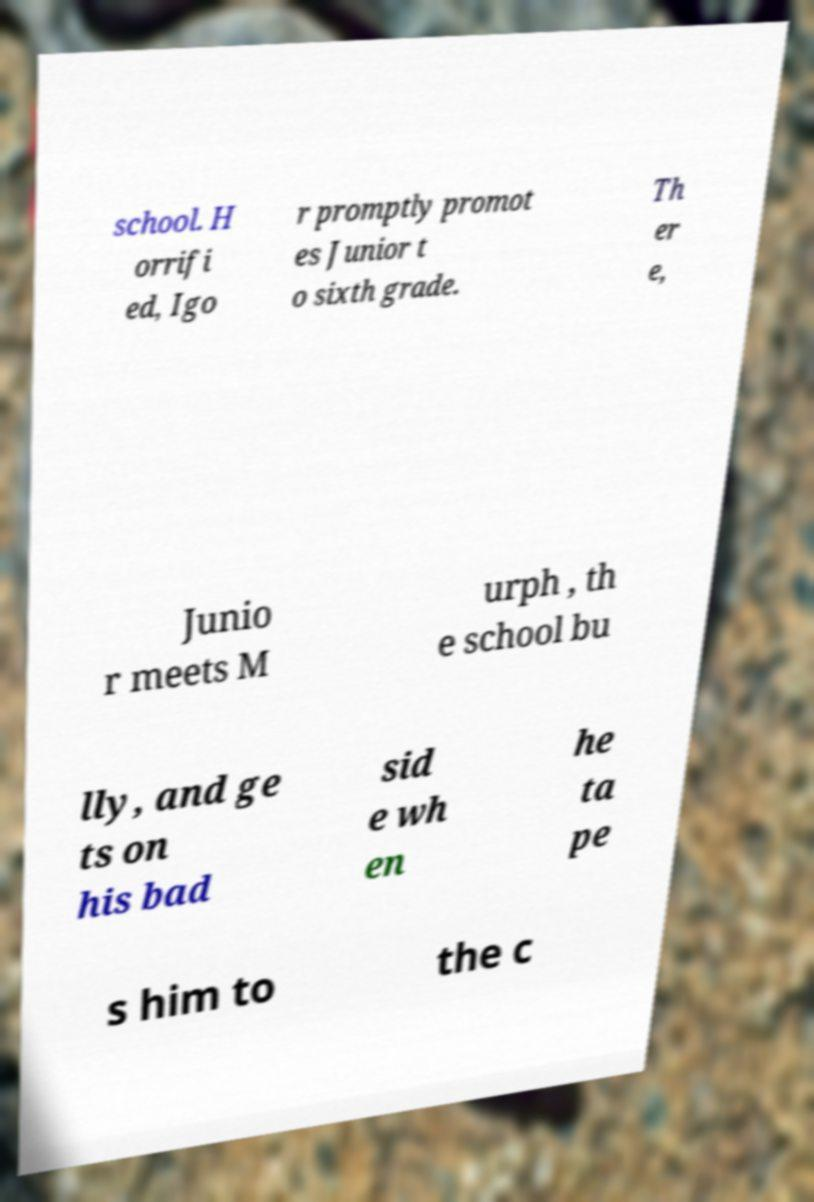What messages or text are displayed in this image? I need them in a readable, typed format. school. H orrifi ed, Igo r promptly promot es Junior t o sixth grade. Th er e, Junio r meets M urph , th e school bu lly, and ge ts on his bad sid e wh en he ta pe s him to the c 